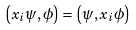Convert formula to latex. <formula><loc_0><loc_0><loc_500><loc_500>\left ( x _ { i } \psi , \phi \right ) = \left ( \psi , x _ { i } \phi \right )</formula> 